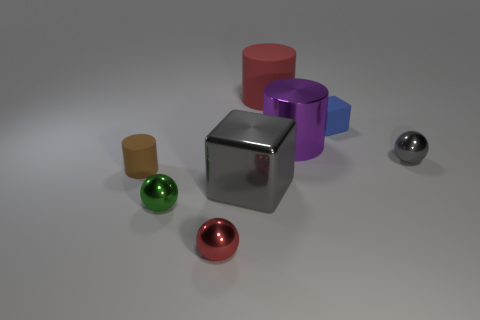There is a small ball that is the same color as the large block; what is it made of?
Offer a terse response. Metal. What number of matte things are brown things or red objects?
Offer a terse response. 2. There is a big cylinder that is on the right side of the large red rubber cylinder; how many tiny green shiny spheres are in front of it?
Your response must be concise. 1. What is the shape of the large object that is both in front of the tiny cube and on the left side of the large purple metal thing?
Give a very brief answer. Cube. The tiny thing that is behind the big metallic cylinder behind the rubber cylinder in front of the large rubber cylinder is made of what material?
Offer a terse response. Rubber. What is the size of the sphere that is the same color as the big block?
Keep it short and to the point. Small. What material is the large purple cylinder?
Your response must be concise. Metal. Is the material of the large purple object the same as the gray sphere right of the green sphere?
Provide a succinct answer. Yes. There is a small rubber thing that is behind the rubber cylinder that is in front of the red rubber thing; what color is it?
Make the answer very short. Blue. There is a object that is on the left side of the tiny red object and behind the tiny green ball; how big is it?
Keep it short and to the point. Small. 